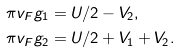Convert formula to latex. <formula><loc_0><loc_0><loc_500><loc_500>\pi v _ { F } g _ { 1 } & = U / 2 - V _ { 2 } , \\ \pi v _ { F } g _ { 2 } & = U / 2 + V _ { 1 } + V _ { 2 } .</formula> 